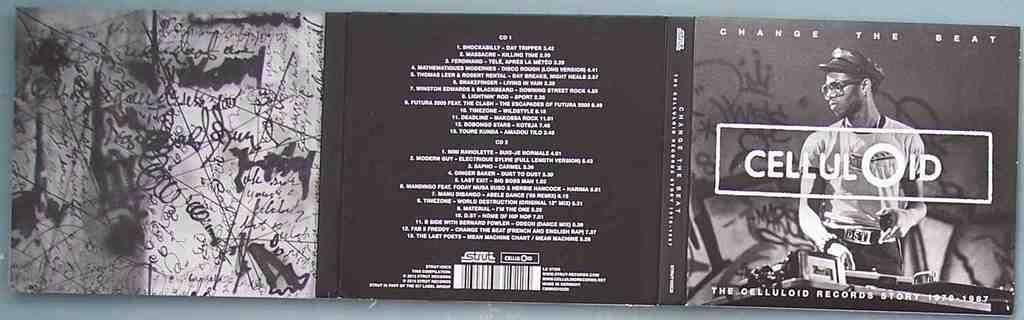<image>
Share a concise interpretation of the image provided. An unfolded dust jacket for a CD about celluloid 